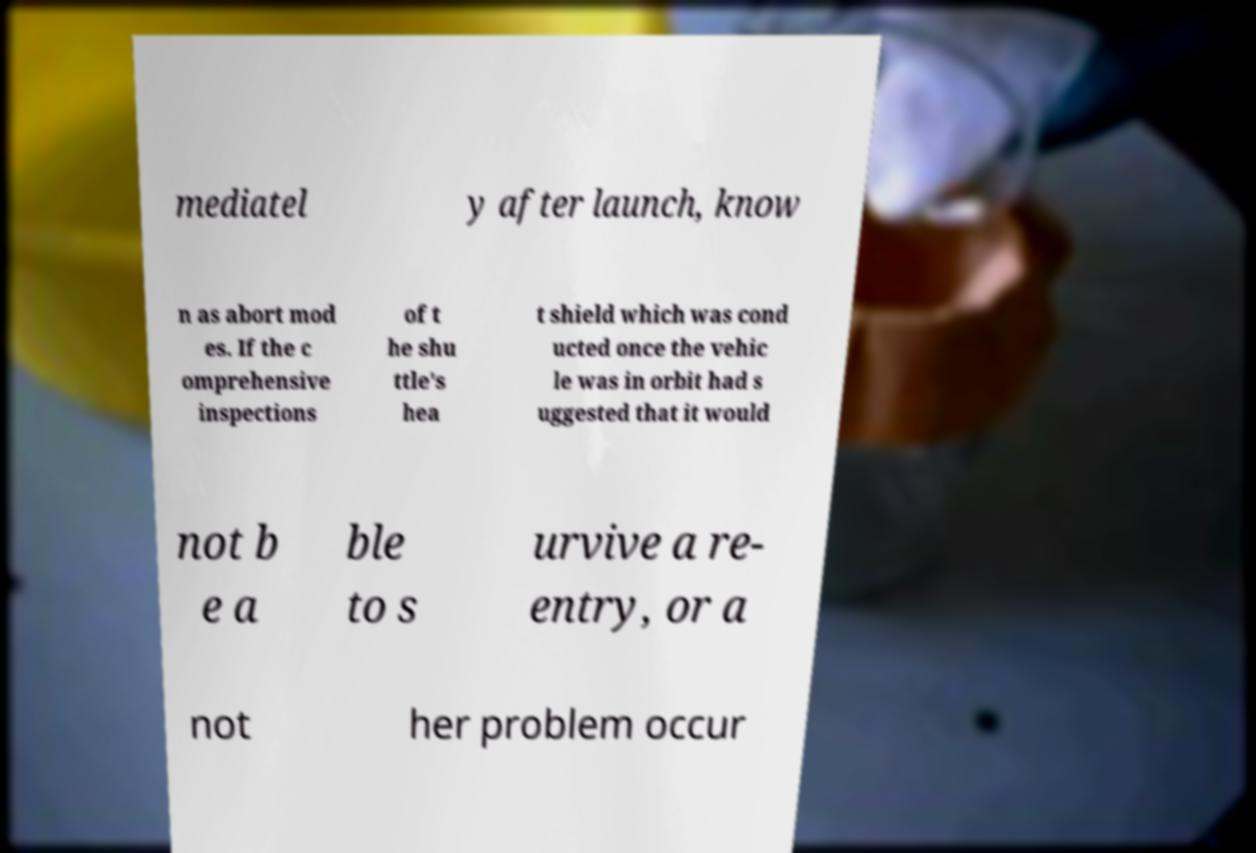I need the written content from this picture converted into text. Can you do that? mediatel y after launch, know n as abort mod es. If the c omprehensive inspections of t he shu ttle's hea t shield which was cond ucted once the vehic le was in orbit had s uggested that it would not b e a ble to s urvive a re- entry, or a not her problem occur 